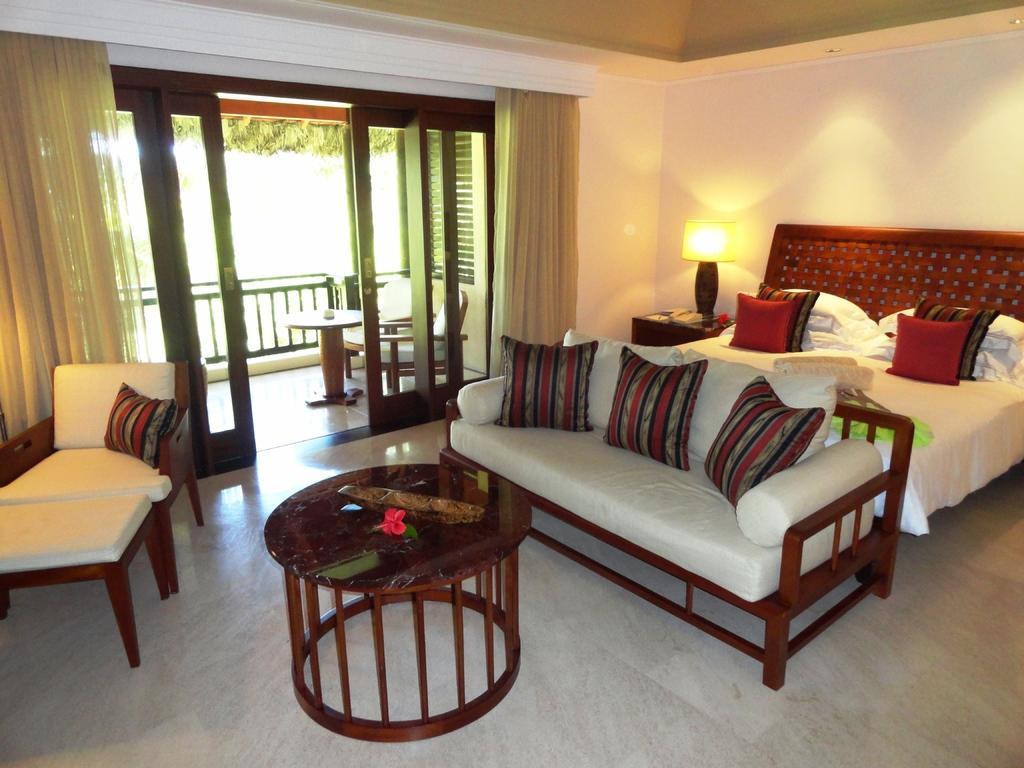In one or two sentences, can you explain what this image depicts? In this picture i could see a room in which there is a cot with bed and pillows on it and in front of the cot there is a sofa with pillows and a center piece table and in the corner there is a corner table on which there is a lamp in the background i could see a glass window. 